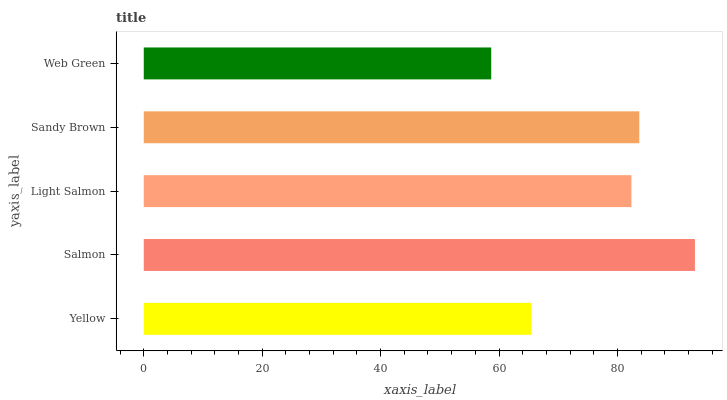Is Web Green the minimum?
Answer yes or no. Yes. Is Salmon the maximum?
Answer yes or no. Yes. Is Light Salmon the minimum?
Answer yes or no. No. Is Light Salmon the maximum?
Answer yes or no. No. Is Salmon greater than Light Salmon?
Answer yes or no. Yes. Is Light Salmon less than Salmon?
Answer yes or no. Yes. Is Light Salmon greater than Salmon?
Answer yes or no. No. Is Salmon less than Light Salmon?
Answer yes or no. No. Is Light Salmon the high median?
Answer yes or no. Yes. Is Light Salmon the low median?
Answer yes or no. Yes. Is Sandy Brown the high median?
Answer yes or no. No. Is Web Green the low median?
Answer yes or no. No. 